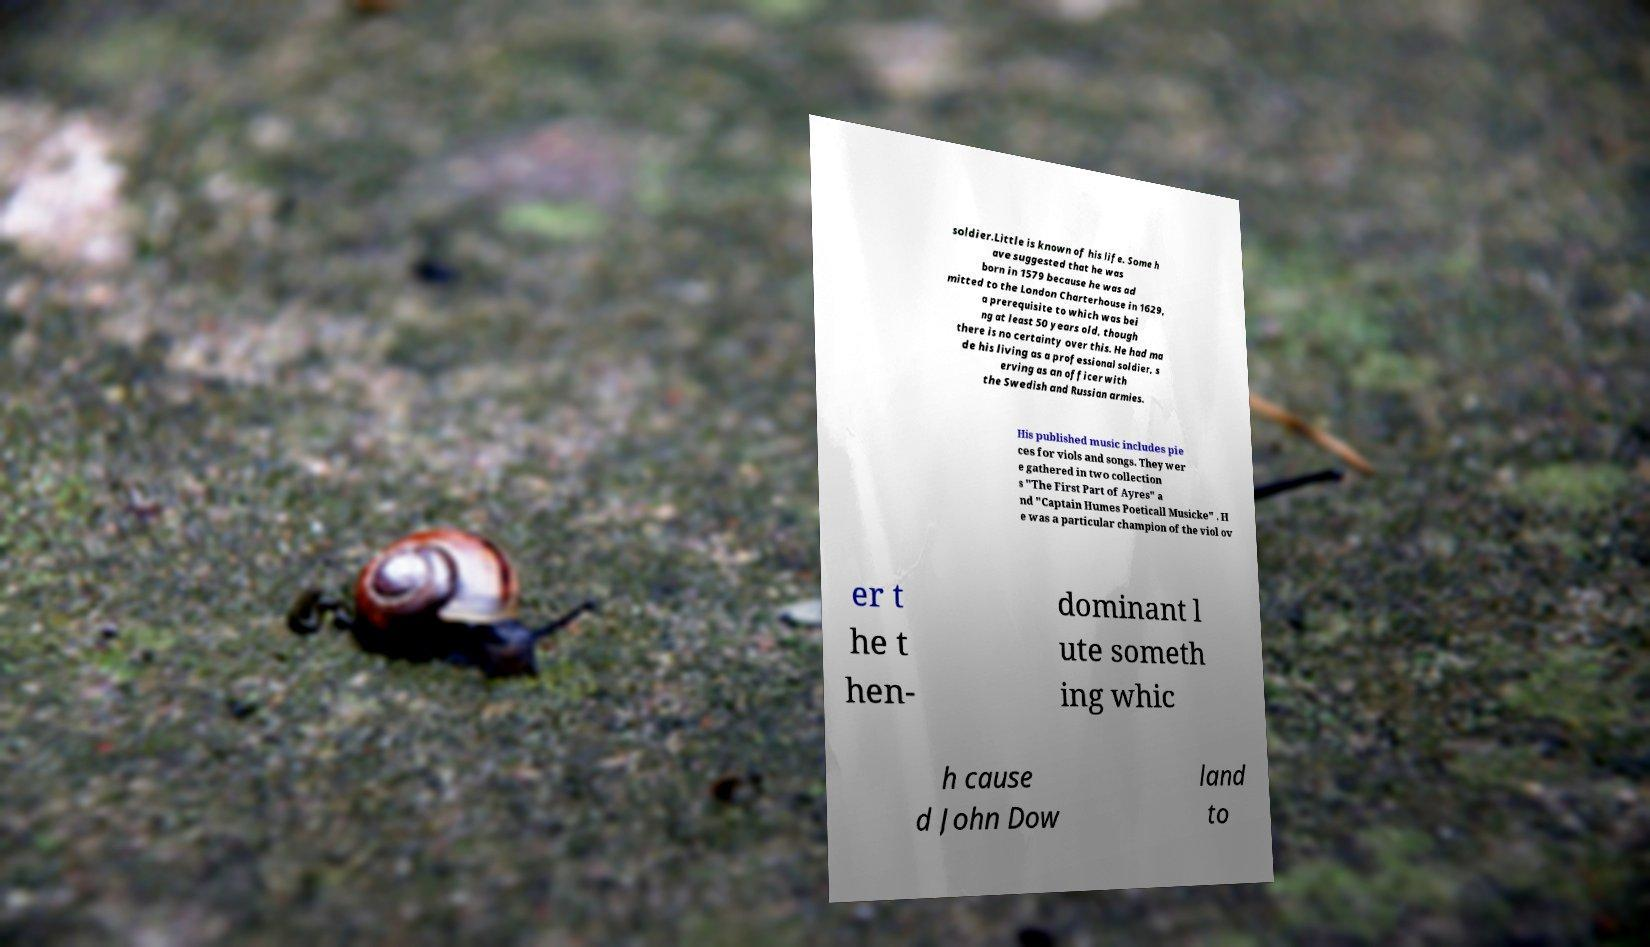Can you read and provide the text displayed in the image?This photo seems to have some interesting text. Can you extract and type it out for me? soldier.Little is known of his life. Some h ave suggested that he was born in 1579 because he was ad mitted to the London Charterhouse in 1629, a prerequisite to which was bei ng at least 50 years old, though there is no certainty over this. He had ma de his living as a professional soldier, s erving as an officer with the Swedish and Russian armies. His published music includes pie ces for viols and songs. They wer e gathered in two collection s "The First Part of Ayres" a nd "Captain Humes Poeticall Musicke" . H e was a particular champion of the viol ov er t he t hen- dominant l ute someth ing whic h cause d John Dow land to 